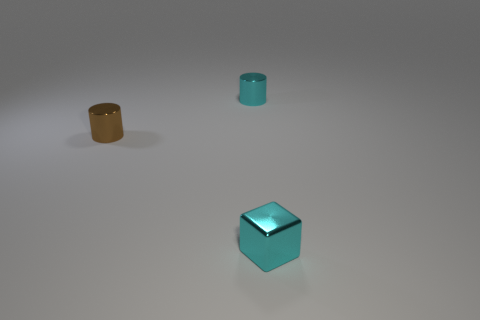Considering their size, if they were scaled to actual objects, what could they represent? If scaled to actual objects, the cube could resemble an architectural element or a metal die, whereas the cylinder might be akin to a container or a segment of piping. 